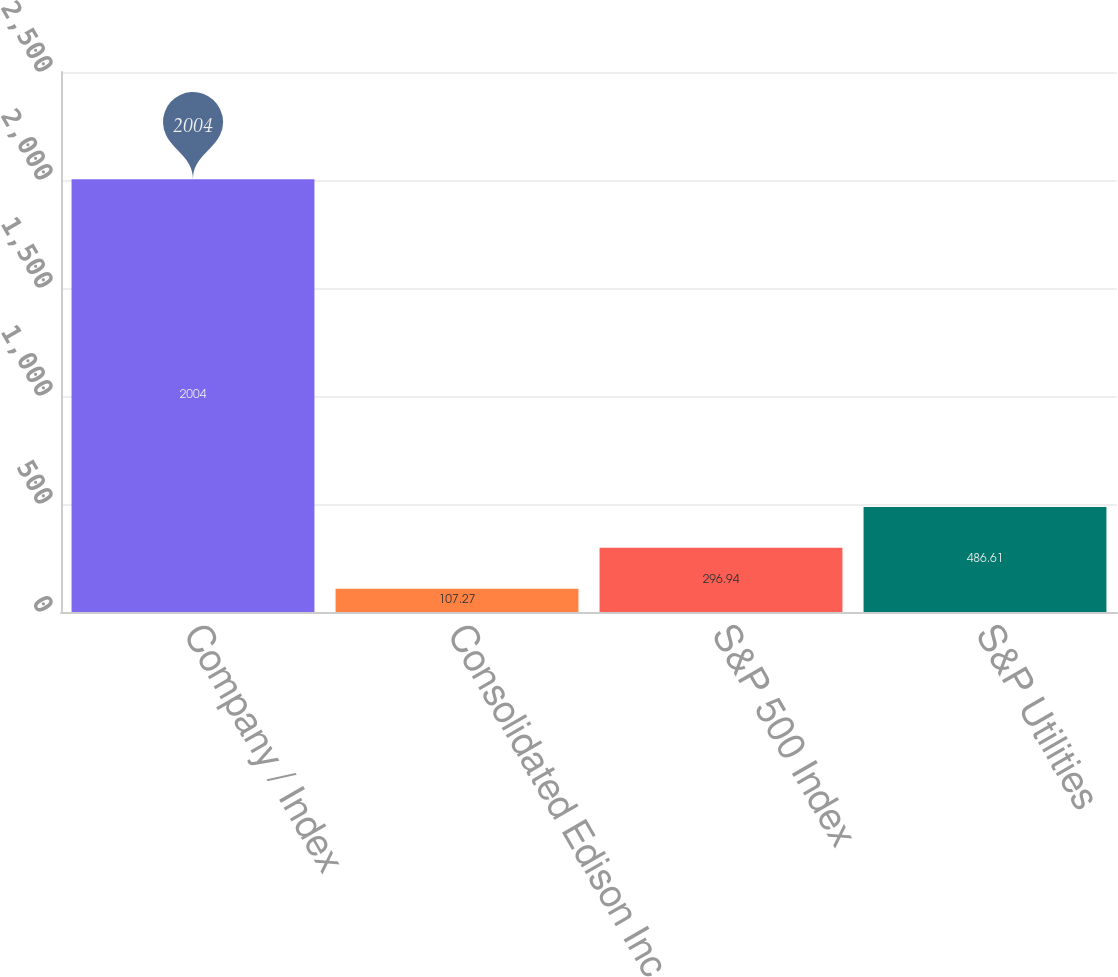Convert chart to OTSL. <chart><loc_0><loc_0><loc_500><loc_500><bar_chart><fcel>Company / Index<fcel>Consolidated Edison Inc<fcel>S&P 500 Index<fcel>S&P Utilities<nl><fcel>2004<fcel>107.27<fcel>296.94<fcel>486.61<nl></chart> 